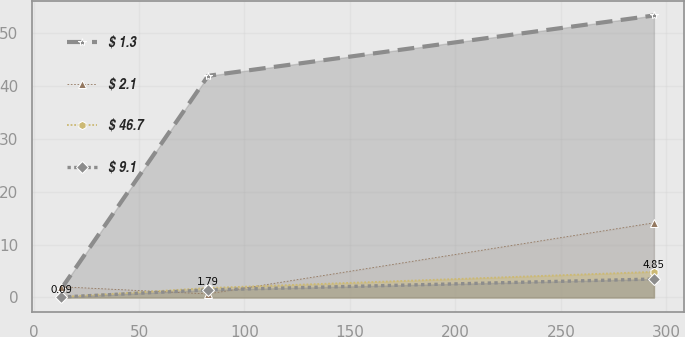<chart> <loc_0><loc_0><loc_500><loc_500><line_chart><ecel><fcel>$ 1.3<fcel>$ 2.1<fcel>$ 46.7<fcel>$ 9.1<nl><fcel>13.14<fcel>1.65<fcel>2.02<fcel>0.09<fcel>0.09<nl><fcel>82.73<fcel>41.96<fcel>0.67<fcel>1.79<fcel>1.43<nl><fcel>294.11<fcel>53.38<fcel>14.13<fcel>4.85<fcel>3.49<nl></chart> 